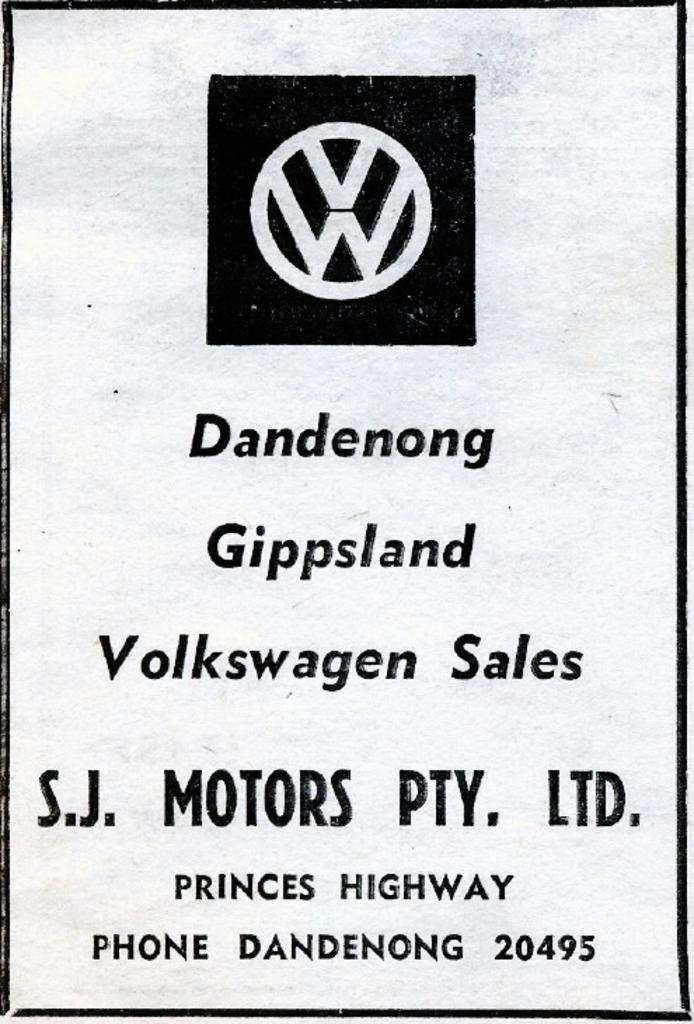Provide a one-sentence caption for the provided image. A black and white poster for Volkswagen Sales featured in Dandenog Gippsland for SJ Motors PTY LTD. 